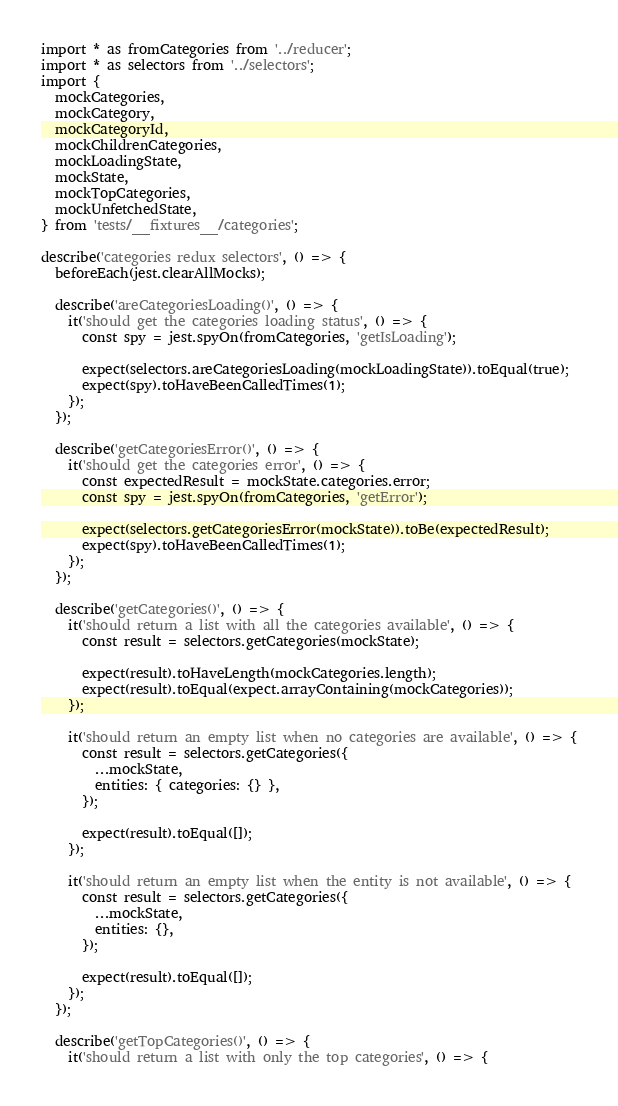Convert code to text. <code><loc_0><loc_0><loc_500><loc_500><_JavaScript_>import * as fromCategories from '../reducer';
import * as selectors from '../selectors';
import {
  mockCategories,
  mockCategory,
  mockCategoryId,
  mockChildrenCategories,
  mockLoadingState,
  mockState,
  mockTopCategories,
  mockUnfetchedState,
} from 'tests/__fixtures__/categories';

describe('categories redux selectors', () => {
  beforeEach(jest.clearAllMocks);

  describe('areCategoriesLoading()', () => {
    it('should get the categories loading status', () => {
      const spy = jest.spyOn(fromCategories, 'getIsLoading');

      expect(selectors.areCategoriesLoading(mockLoadingState)).toEqual(true);
      expect(spy).toHaveBeenCalledTimes(1);
    });
  });

  describe('getCategoriesError()', () => {
    it('should get the categories error', () => {
      const expectedResult = mockState.categories.error;
      const spy = jest.spyOn(fromCategories, 'getError');

      expect(selectors.getCategoriesError(mockState)).toBe(expectedResult);
      expect(spy).toHaveBeenCalledTimes(1);
    });
  });

  describe('getCategories()', () => {
    it('should return a list with all the categories available', () => {
      const result = selectors.getCategories(mockState);

      expect(result).toHaveLength(mockCategories.length);
      expect(result).toEqual(expect.arrayContaining(mockCategories));
    });

    it('should return an empty list when no categories are available', () => {
      const result = selectors.getCategories({
        ...mockState,
        entities: { categories: {} },
      });

      expect(result).toEqual([]);
    });

    it('should return an empty list when the entity is not available', () => {
      const result = selectors.getCategories({
        ...mockState,
        entities: {},
      });

      expect(result).toEqual([]);
    });
  });

  describe('getTopCategories()', () => {
    it('should return a list with only the top categories', () => {</code> 